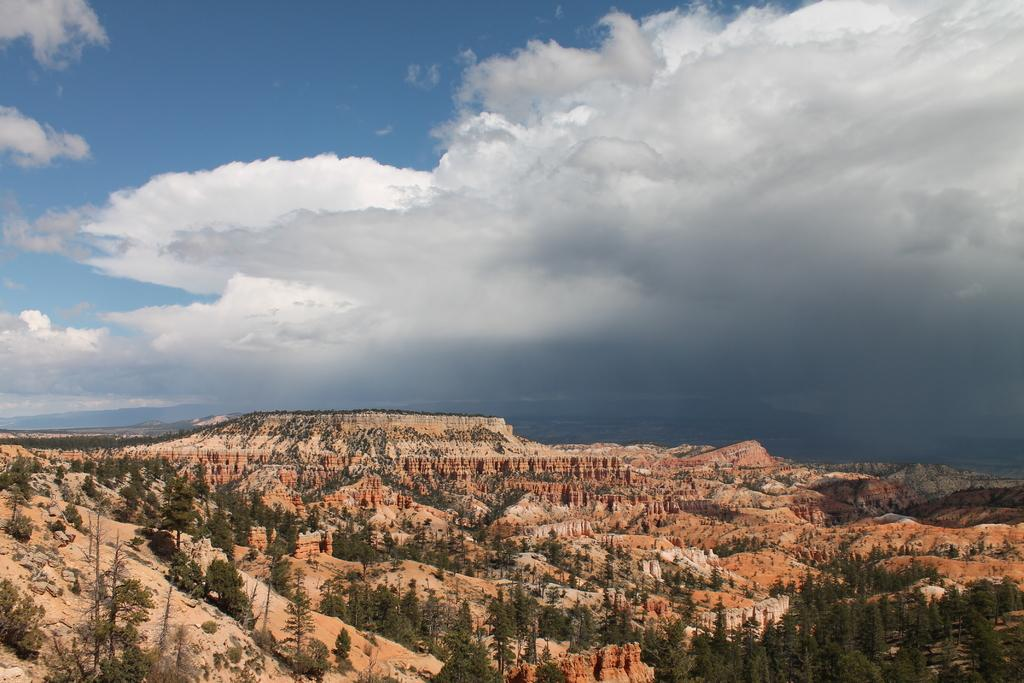What type of natural formation can be seen in the image? There are mountains in the image. What type of vegetation is present at the base of the mountains? There are trees at the bottom of the image. What part of the natural environment is visible in the image? The sky is visible at the top of the image. What type of cakes can be smelled in the image? There are no cakes present in the image, so it is not possible to determine what they might smell like. 